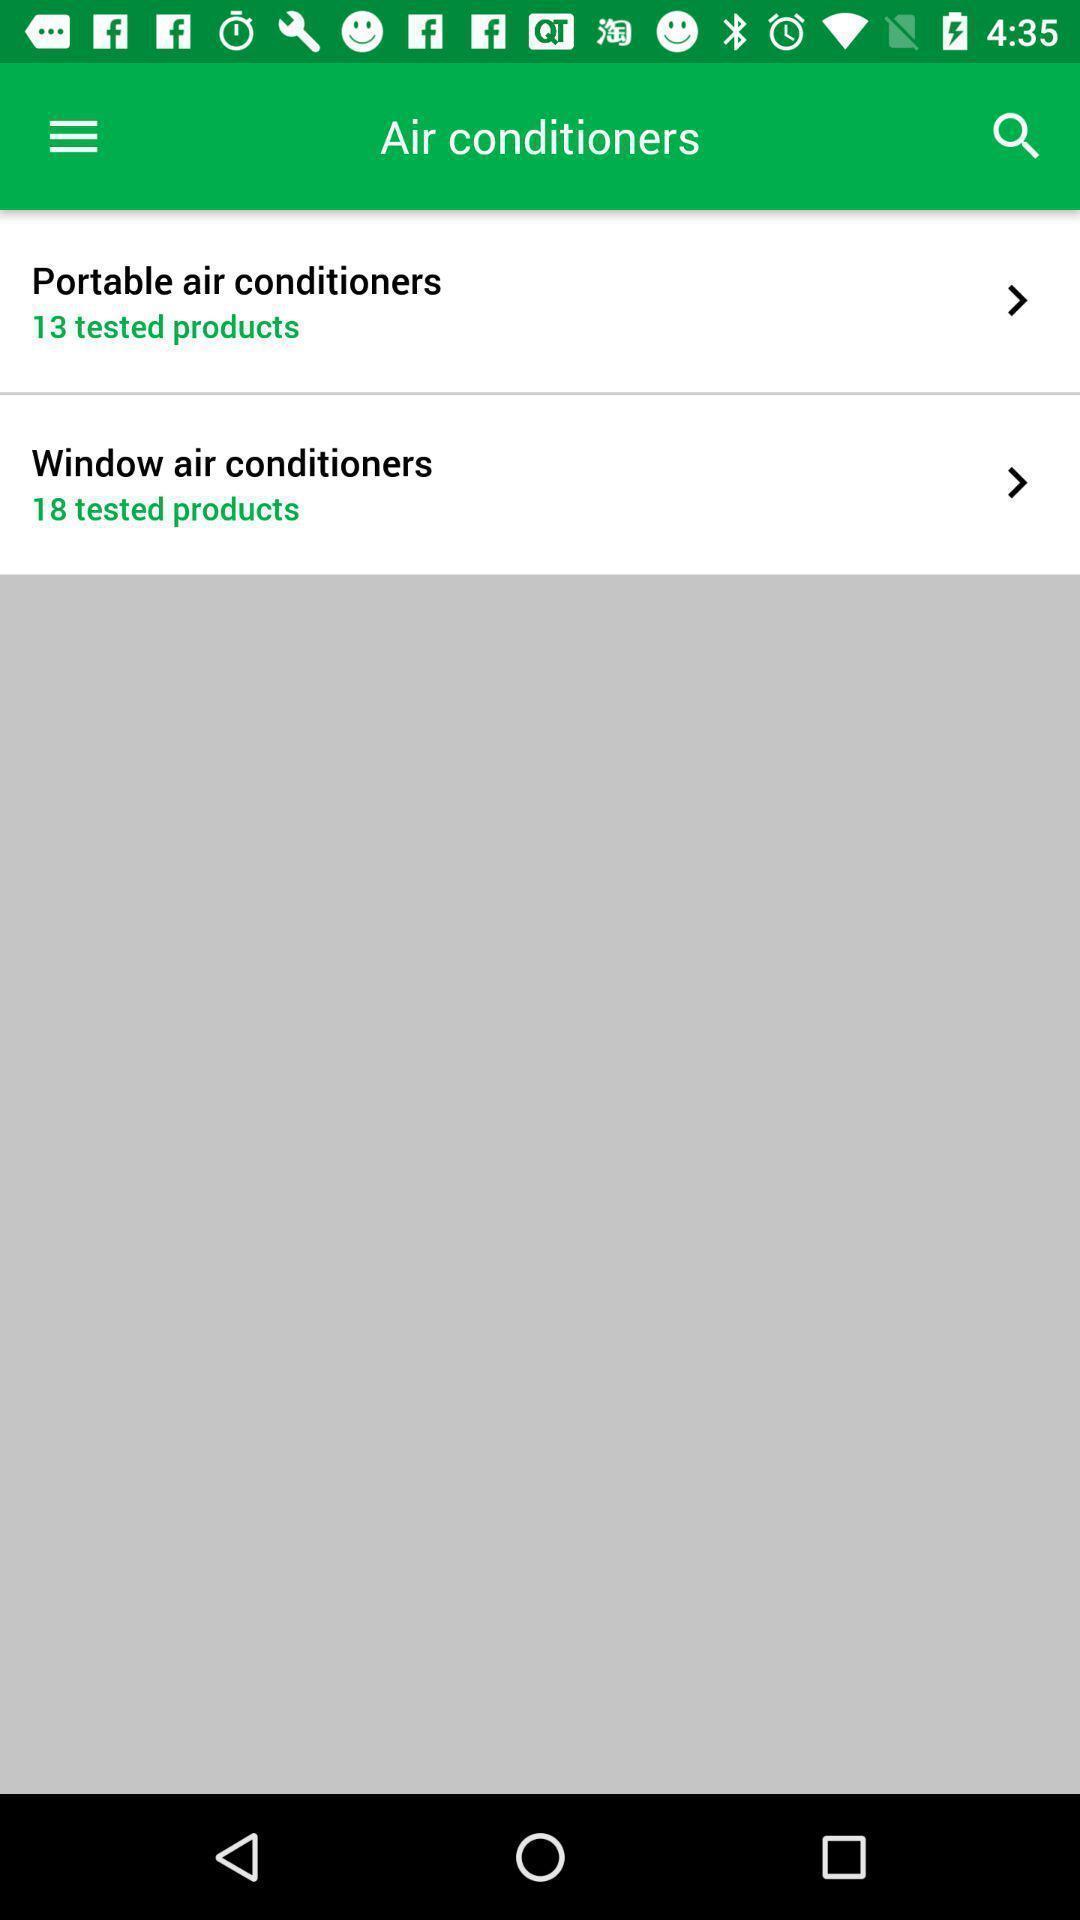Tell me what you see in this picture. Screen showing categories of air conditioners. 